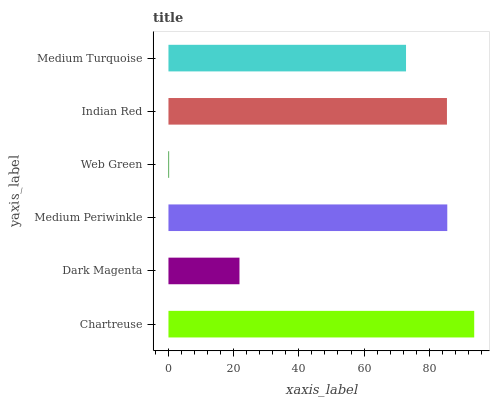Is Web Green the minimum?
Answer yes or no. Yes. Is Chartreuse the maximum?
Answer yes or no. Yes. Is Dark Magenta the minimum?
Answer yes or no. No. Is Dark Magenta the maximum?
Answer yes or no. No. Is Chartreuse greater than Dark Magenta?
Answer yes or no. Yes. Is Dark Magenta less than Chartreuse?
Answer yes or no. Yes. Is Dark Magenta greater than Chartreuse?
Answer yes or no. No. Is Chartreuse less than Dark Magenta?
Answer yes or no. No. Is Indian Red the high median?
Answer yes or no. Yes. Is Medium Turquoise the low median?
Answer yes or no. Yes. Is Medium Turquoise the high median?
Answer yes or no. No. Is Indian Red the low median?
Answer yes or no. No. 